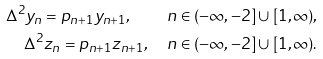<formula> <loc_0><loc_0><loc_500><loc_500>\Delta ^ { 2 } y _ { n } = p _ { n + 1 } y _ { n + 1 } , \quad n \in ( - \infty , - 2 ] \cup [ 1 , \infty ) , \\ \Delta ^ { 2 } z _ { n } = p _ { n + 1 } z _ { n + 1 } , \quad n \in ( - \infty , - 2 ] \cup [ 1 , \infty ) .</formula> 